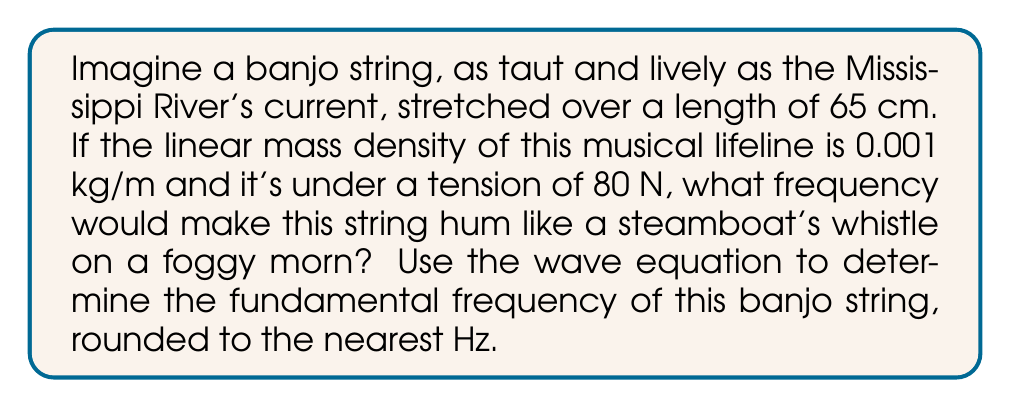Provide a solution to this math problem. Let's pluck this problem like a banjo string, shall we?

1) The wave equation for a vibrating string is given by:

   $$v = \sqrt{\frac{T}{\mu}}$$

   Where $v$ is the wave velocity, $T$ is the tension, and $\mu$ is the linear mass density.

2) We're given:
   - Length (L) = 65 cm = 0.65 m
   - Linear mass density ($\mu$) = 0.001 kg/m
   - Tension (T) = 80 N

3) Let's calculate the wave velocity:

   $$v = \sqrt{\frac{80}{0.001}} = \sqrt{80000} \approx 282.84 \text{ m/s}$$

4) Now, we need to use the relationship between wavelength ($\lambda$), frequency (f), and wave velocity (v):

   $$v = f\lambda$$

5) For the fundamental frequency, the wavelength is twice the length of the string:

   $$\lambda = 2L = 2(0.65) = 1.3 \text{ m}$$

6) Substituting this into our equation:

   $$282.84 = f(1.3)$$

7) Solving for f:

   $$f = \frac{282.84}{1.3} \approx 217.57 \text{ Hz}$$

8) Rounding to the nearest Hz:

   $$f \approx 218 \text{ Hz}$$

And there you have it, as clear as the twang of a banjo on a summer's eve!
Answer: 218 Hz 